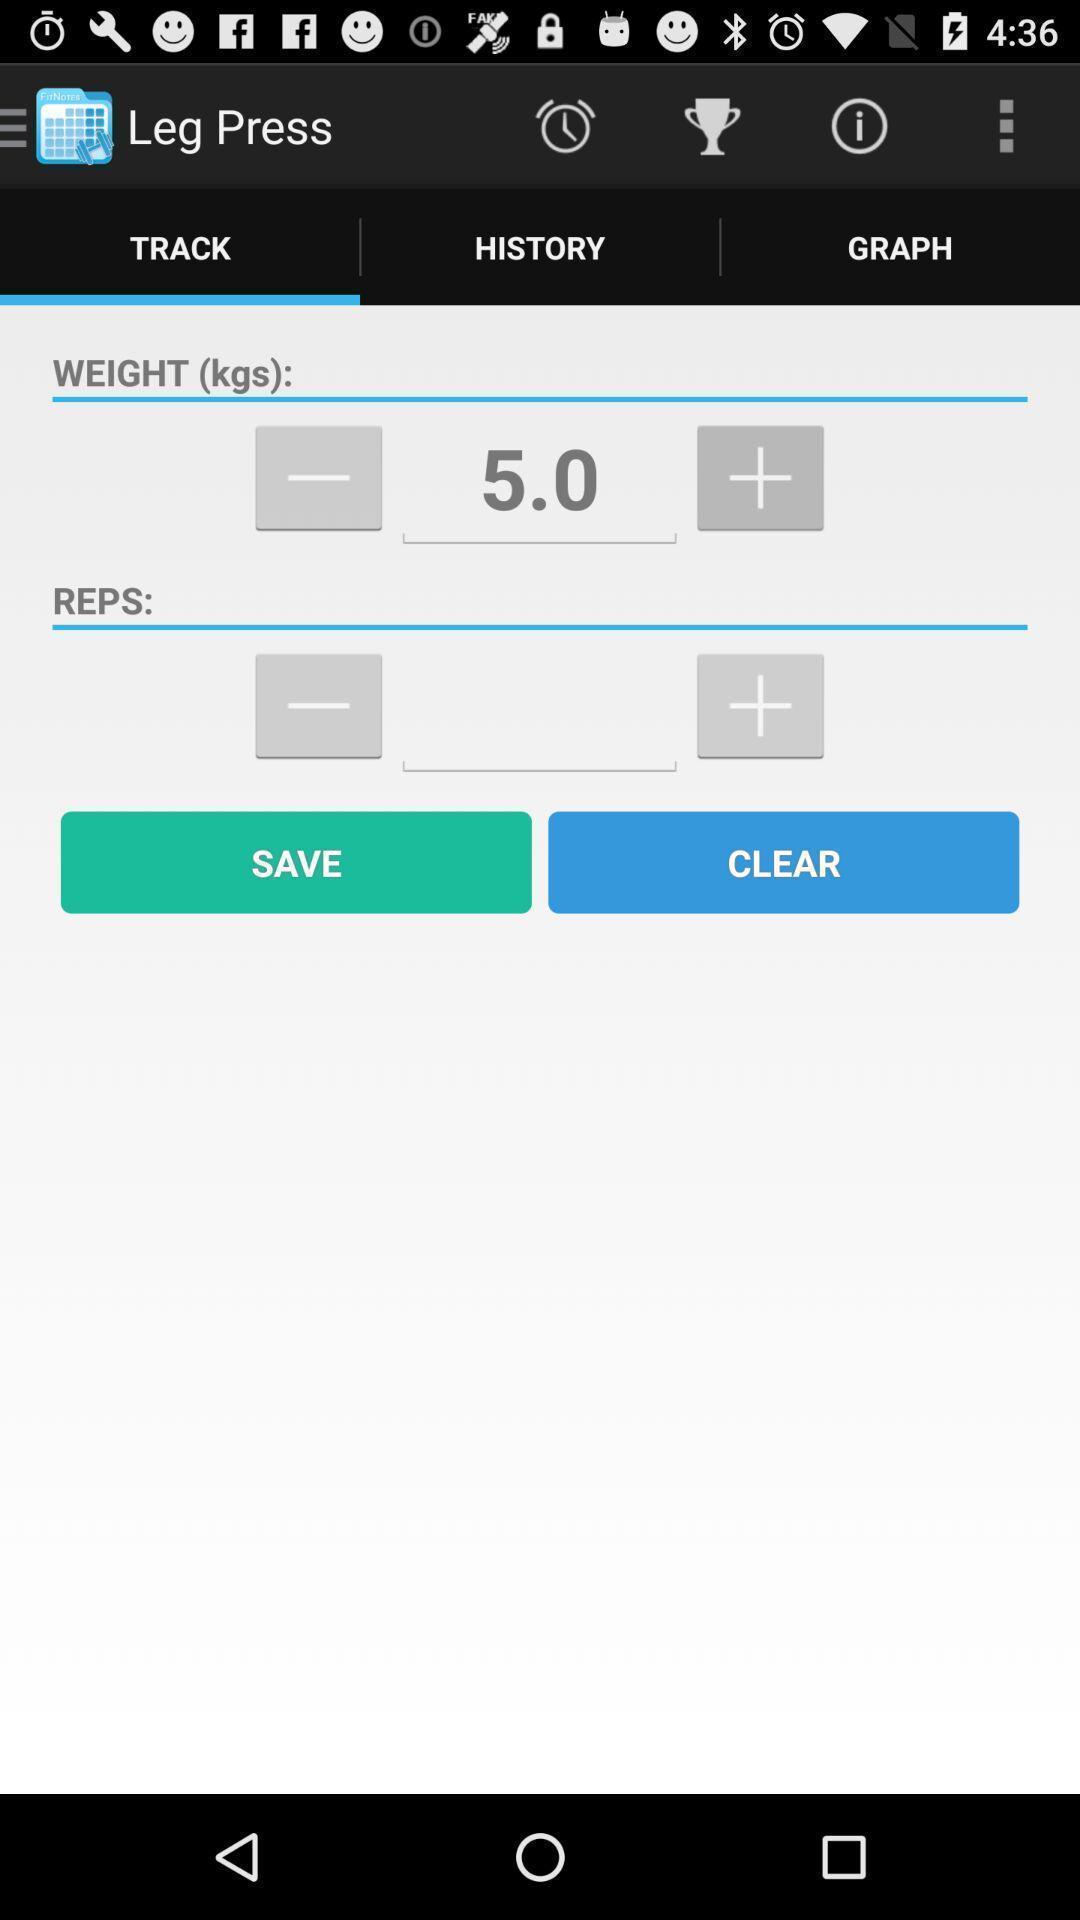Describe the content in this image. Screen shows tracking page in workout tracker app. 